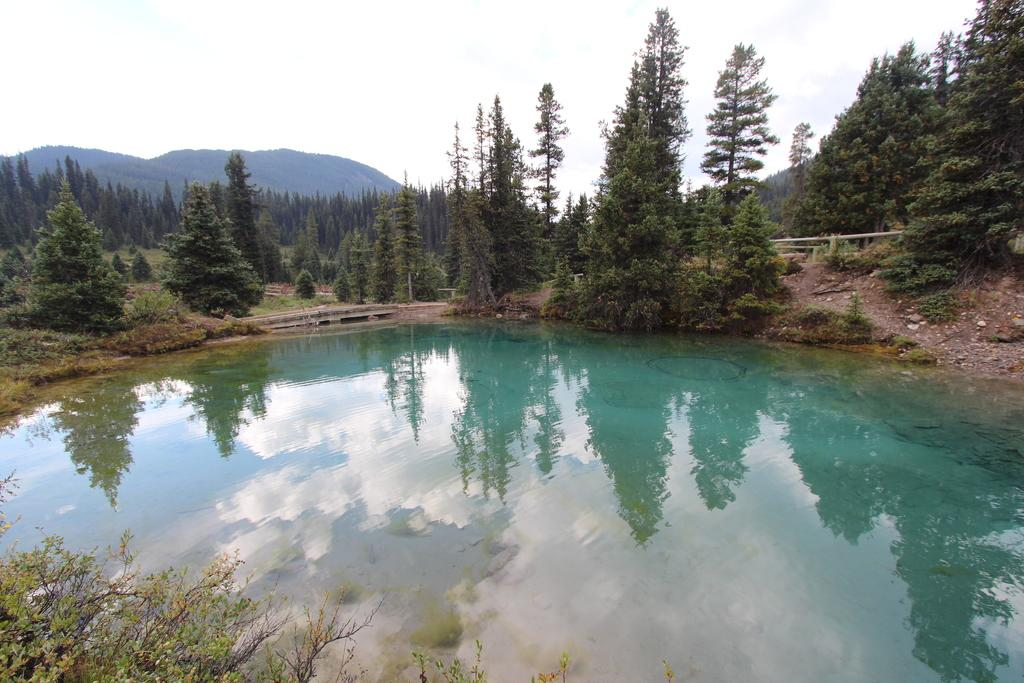What is visible in the foreground of the image? There is water in the foreground of the image. What can be seen in the background of the image? There is a group of trees, a fence, mountains, and the sky visible in the background of the image. Can you describe the landscape in the image? The landscape features water in the foreground and a combination of trees, a fence, mountains, and the sky in the background. Can you see an owl perched on the fence in the image? There is no owl present in the image; it only features water, trees, a fence, mountains, and the sky. Is there a building visible in the image? There is no building visible in the image; it only features water, trees, a fence, mountains, and the sky. 